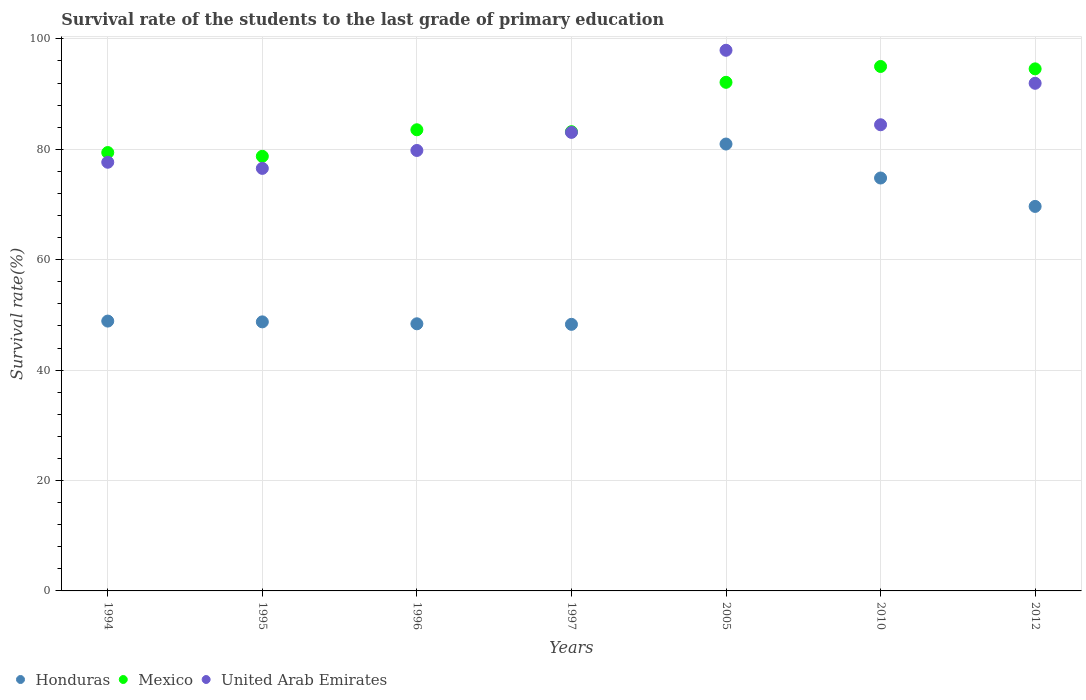How many different coloured dotlines are there?
Provide a succinct answer. 3. What is the survival rate of the students in Mexico in 2005?
Your response must be concise. 92.14. Across all years, what is the maximum survival rate of the students in Mexico?
Offer a terse response. 95.01. Across all years, what is the minimum survival rate of the students in Honduras?
Offer a very short reply. 48.29. In which year was the survival rate of the students in Mexico maximum?
Make the answer very short. 2010. In which year was the survival rate of the students in United Arab Emirates minimum?
Provide a succinct answer. 1995. What is the total survival rate of the students in United Arab Emirates in the graph?
Your answer should be very brief. 591.4. What is the difference between the survival rate of the students in Mexico in 1994 and that in 2010?
Offer a terse response. -15.59. What is the difference between the survival rate of the students in Mexico in 1997 and the survival rate of the students in Honduras in 2012?
Your response must be concise. 13.54. What is the average survival rate of the students in United Arab Emirates per year?
Give a very brief answer. 84.49. In the year 2010, what is the difference between the survival rate of the students in United Arab Emirates and survival rate of the students in Honduras?
Offer a terse response. 9.65. What is the ratio of the survival rate of the students in Mexico in 1994 to that in 1996?
Your answer should be very brief. 0.95. What is the difference between the highest and the second highest survival rate of the students in Mexico?
Your answer should be compact. 0.43. What is the difference between the highest and the lowest survival rate of the students in Mexico?
Make the answer very short. 16.28. In how many years, is the survival rate of the students in Mexico greater than the average survival rate of the students in Mexico taken over all years?
Offer a very short reply. 3. Is it the case that in every year, the sum of the survival rate of the students in Honduras and survival rate of the students in Mexico  is greater than the survival rate of the students in United Arab Emirates?
Ensure brevity in your answer.  Yes. Is the survival rate of the students in United Arab Emirates strictly less than the survival rate of the students in Honduras over the years?
Provide a short and direct response. No. How many dotlines are there?
Ensure brevity in your answer.  3. Are the values on the major ticks of Y-axis written in scientific E-notation?
Offer a terse response. No. Does the graph contain any zero values?
Keep it short and to the point. No. Does the graph contain grids?
Give a very brief answer. Yes. Where does the legend appear in the graph?
Provide a succinct answer. Bottom left. What is the title of the graph?
Ensure brevity in your answer.  Survival rate of the students to the last grade of primary education. Does "India" appear as one of the legend labels in the graph?
Make the answer very short. No. What is the label or title of the Y-axis?
Your answer should be compact. Survival rate(%). What is the Survival rate(%) of Honduras in 1994?
Your answer should be compact. 48.88. What is the Survival rate(%) in Mexico in 1994?
Provide a short and direct response. 79.41. What is the Survival rate(%) in United Arab Emirates in 1994?
Make the answer very short. 77.66. What is the Survival rate(%) in Honduras in 1995?
Make the answer very short. 48.74. What is the Survival rate(%) of Mexico in 1995?
Offer a terse response. 78.73. What is the Survival rate(%) of United Arab Emirates in 1995?
Your answer should be very brief. 76.54. What is the Survival rate(%) of Honduras in 1996?
Ensure brevity in your answer.  48.39. What is the Survival rate(%) in Mexico in 1996?
Ensure brevity in your answer.  83.54. What is the Survival rate(%) of United Arab Emirates in 1996?
Your response must be concise. 79.79. What is the Survival rate(%) in Honduras in 1997?
Provide a short and direct response. 48.29. What is the Survival rate(%) of Mexico in 1997?
Your answer should be compact. 83.19. What is the Survival rate(%) of United Arab Emirates in 1997?
Your answer should be very brief. 83.06. What is the Survival rate(%) of Honduras in 2005?
Make the answer very short. 80.96. What is the Survival rate(%) of Mexico in 2005?
Give a very brief answer. 92.14. What is the Survival rate(%) of United Arab Emirates in 2005?
Give a very brief answer. 97.94. What is the Survival rate(%) in Honduras in 2010?
Provide a succinct answer. 74.8. What is the Survival rate(%) of Mexico in 2010?
Offer a very short reply. 95.01. What is the Survival rate(%) of United Arab Emirates in 2010?
Keep it short and to the point. 84.45. What is the Survival rate(%) in Honduras in 2012?
Provide a succinct answer. 69.65. What is the Survival rate(%) in Mexico in 2012?
Your answer should be very brief. 94.57. What is the Survival rate(%) in United Arab Emirates in 2012?
Keep it short and to the point. 91.96. Across all years, what is the maximum Survival rate(%) of Honduras?
Your response must be concise. 80.96. Across all years, what is the maximum Survival rate(%) in Mexico?
Offer a terse response. 95.01. Across all years, what is the maximum Survival rate(%) in United Arab Emirates?
Provide a short and direct response. 97.94. Across all years, what is the minimum Survival rate(%) in Honduras?
Give a very brief answer. 48.29. Across all years, what is the minimum Survival rate(%) of Mexico?
Offer a very short reply. 78.73. Across all years, what is the minimum Survival rate(%) in United Arab Emirates?
Provide a short and direct response. 76.54. What is the total Survival rate(%) in Honduras in the graph?
Keep it short and to the point. 419.72. What is the total Survival rate(%) of Mexico in the graph?
Make the answer very short. 606.59. What is the total Survival rate(%) of United Arab Emirates in the graph?
Your response must be concise. 591.4. What is the difference between the Survival rate(%) of Honduras in 1994 and that in 1995?
Offer a very short reply. 0.14. What is the difference between the Survival rate(%) in Mexico in 1994 and that in 1995?
Make the answer very short. 0.68. What is the difference between the Survival rate(%) of United Arab Emirates in 1994 and that in 1995?
Your response must be concise. 1.11. What is the difference between the Survival rate(%) in Honduras in 1994 and that in 1996?
Offer a terse response. 0.49. What is the difference between the Survival rate(%) in Mexico in 1994 and that in 1996?
Your answer should be compact. -4.13. What is the difference between the Survival rate(%) of United Arab Emirates in 1994 and that in 1996?
Provide a short and direct response. -2.13. What is the difference between the Survival rate(%) in Honduras in 1994 and that in 1997?
Provide a short and direct response. 0.59. What is the difference between the Survival rate(%) in Mexico in 1994 and that in 1997?
Keep it short and to the point. -3.78. What is the difference between the Survival rate(%) in United Arab Emirates in 1994 and that in 1997?
Offer a terse response. -5.41. What is the difference between the Survival rate(%) in Honduras in 1994 and that in 2005?
Keep it short and to the point. -32.07. What is the difference between the Survival rate(%) in Mexico in 1994 and that in 2005?
Your answer should be compact. -12.72. What is the difference between the Survival rate(%) in United Arab Emirates in 1994 and that in 2005?
Keep it short and to the point. -20.28. What is the difference between the Survival rate(%) in Honduras in 1994 and that in 2010?
Provide a short and direct response. -25.92. What is the difference between the Survival rate(%) in Mexico in 1994 and that in 2010?
Your response must be concise. -15.59. What is the difference between the Survival rate(%) in United Arab Emirates in 1994 and that in 2010?
Offer a terse response. -6.79. What is the difference between the Survival rate(%) of Honduras in 1994 and that in 2012?
Offer a terse response. -20.77. What is the difference between the Survival rate(%) in Mexico in 1994 and that in 2012?
Ensure brevity in your answer.  -15.16. What is the difference between the Survival rate(%) of United Arab Emirates in 1994 and that in 2012?
Provide a short and direct response. -14.3. What is the difference between the Survival rate(%) in Honduras in 1995 and that in 1996?
Provide a short and direct response. 0.35. What is the difference between the Survival rate(%) of Mexico in 1995 and that in 1996?
Make the answer very short. -4.81. What is the difference between the Survival rate(%) of United Arab Emirates in 1995 and that in 1996?
Keep it short and to the point. -3.25. What is the difference between the Survival rate(%) of Honduras in 1995 and that in 1997?
Give a very brief answer. 0.45. What is the difference between the Survival rate(%) in Mexico in 1995 and that in 1997?
Provide a short and direct response. -4.46. What is the difference between the Survival rate(%) of United Arab Emirates in 1995 and that in 1997?
Your response must be concise. -6.52. What is the difference between the Survival rate(%) of Honduras in 1995 and that in 2005?
Your answer should be very brief. -32.22. What is the difference between the Survival rate(%) of Mexico in 1995 and that in 2005?
Give a very brief answer. -13.41. What is the difference between the Survival rate(%) in United Arab Emirates in 1995 and that in 2005?
Keep it short and to the point. -21.39. What is the difference between the Survival rate(%) of Honduras in 1995 and that in 2010?
Offer a very short reply. -26.06. What is the difference between the Survival rate(%) in Mexico in 1995 and that in 2010?
Offer a terse response. -16.28. What is the difference between the Survival rate(%) in United Arab Emirates in 1995 and that in 2010?
Offer a very short reply. -7.9. What is the difference between the Survival rate(%) in Honduras in 1995 and that in 2012?
Your answer should be very brief. -20.92. What is the difference between the Survival rate(%) in Mexico in 1995 and that in 2012?
Offer a terse response. -15.84. What is the difference between the Survival rate(%) of United Arab Emirates in 1995 and that in 2012?
Your answer should be very brief. -15.41. What is the difference between the Survival rate(%) of Honduras in 1996 and that in 1997?
Ensure brevity in your answer.  0.1. What is the difference between the Survival rate(%) of Mexico in 1996 and that in 1997?
Your answer should be very brief. 0.35. What is the difference between the Survival rate(%) in United Arab Emirates in 1996 and that in 1997?
Your response must be concise. -3.28. What is the difference between the Survival rate(%) in Honduras in 1996 and that in 2005?
Keep it short and to the point. -32.56. What is the difference between the Survival rate(%) in Mexico in 1996 and that in 2005?
Offer a terse response. -8.6. What is the difference between the Survival rate(%) of United Arab Emirates in 1996 and that in 2005?
Keep it short and to the point. -18.15. What is the difference between the Survival rate(%) of Honduras in 1996 and that in 2010?
Keep it short and to the point. -26.41. What is the difference between the Survival rate(%) of Mexico in 1996 and that in 2010?
Make the answer very short. -11.47. What is the difference between the Survival rate(%) of United Arab Emirates in 1996 and that in 2010?
Offer a very short reply. -4.66. What is the difference between the Survival rate(%) in Honduras in 1996 and that in 2012?
Ensure brevity in your answer.  -21.26. What is the difference between the Survival rate(%) of Mexico in 1996 and that in 2012?
Your answer should be very brief. -11.03. What is the difference between the Survival rate(%) of United Arab Emirates in 1996 and that in 2012?
Your answer should be compact. -12.17. What is the difference between the Survival rate(%) in Honduras in 1997 and that in 2005?
Your answer should be very brief. -32.66. What is the difference between the Survival rate(%) of Mexico in 1997 and that in 2005?
Provide a short and direct response. -8.95. What is the difference between the Survival rate(%) in United Arab Emirates in 1997 and that in 2005?
Provide a short and direct response. -14.87. What is the difference between the Survival rate(%) in Honduras in 1997 and that in 2010?
Ensure brevity in your answer.  -26.51. What is the difference between the Survival rate(%) of Mexico in 1997 and that in 2010?
Your answer should be compact. -11.82. What is the difference between the Survival rate(%) of United Arab Emirates in 1997 and that in 2010?
Give a very brief answer. -1.38. What is the difference between the Survival rate(%) in Honduras in 1997 and that in 2012?
Provide a short and direct response. -21.36. What is the difference between the Survival rate(%) of Mexico in 1997 and that in 2012?
Offer a very short reply. -11.38. What is the difference between the Survival rate(%) in United Arab Emirates in 1997 and that in 2012?
Ensure brevity in your answer.  -8.89. What is the difference between the Survival rate(%) in Honduras in 2005 and that in 2010?
Offer a terse response. 6.16. What is the difference between the Survival rate(%) of Mexico in 2005 and that in 2010?
Your answer should be very brief. -2.87. What is the difference between the Survival rate(%) in United Arab Emirates in 2005 and that in 2010?
Make the answer very short. 13.49. What is the difference between the Survival rate(%) of Honduras in 2005 and that in 2012?
Offer a terse response. 11.3. What is the difference between the Survival rate(%) of Mexico in 2005 and that in 2012?
Provide a short and direct response. -2.44. What is the difference between the Survival rate(%) of United Arab Emirates in 2005 and that in 2012?
Your response must be concise. 5.98. What is the difference between the Survival rate(%) of Honduras in 2010 and that in 2012?
Provide a short and direct response. 5.14. What is the difference between the Survival rate(%) in Mexico in 2010 and that in 2012?
Offer a terse response. 0.43. What is the difference between the Survival rate(%) of United Arab Emirates in 2010 and that in 2012?
Offer a terse response. -7.51. What is the difference between the Survival rate(%) in Honduras in 1994 and the Survival rate(%) in Mexico in 1995?
Your response must be concise. -29.85. What is the difference between the Survival rate(%) of Honduras in 1994 and the Survival rate(%) of United Arab Emirates in 1995?
Your answer should be compact. -27.66. What is the difference between the Survival rate(%) in Mexico in 1994 and the Survival rate(%) in United Arab Emirates in 1995?
Provide a succinct answer. 2.87. What is the difference between the Survival rate(%) of Honduras in 1994 and the Survival rate(%) of Mexico in 1996?
Offer a very short reply. -34.66. What is the difference between the Survival rate(%) of Honduras in 1994 and the Survival rate(%) of United Arab Emirates in 1996?
Your response must be concise. -30.91. What is the difference between the Survival rate(%) of Mexico in 1994 and the Survival rate(%) of United Arab Emirates in 1996?
Your answer should be very brief. -0.38. What is the difference between the Survival rate(%) in Honduras in 1994 and the Survival rate(%) in Mexico in 1997?
Give a very brief answer. -34.31. What is the difference between the Survival rate(%) of Honduras in 1994 and the Survival rate(%) of United Arab Emirates in 1997?
Provide a succinct answer. -34.18. What is the difference between the Survival rate(%) in Mexico in 1994 and the Survival rate(%) in United Arab Emirates in 1997?
Make the answer very short. -3.65. What is the difference between the Survival rate(%) of Honduras in 1994 and the Survival rate(%) of Mexico in 2005?
Ensure brevity in your answer.  -43.25. What is the difference between the Survival rate(%) of Honduras in 1994 and the Survival rate(%) of United Arab Emirates in 2005?
Provide a succinct answer. -49.06. What is the difference between the Survival rate(%) in Mexico in 1994 and the Survival rate(%) in United Arab Emirates in 2005?
Offer a terse response. -18.53. What is the difference between the Survival rate(%) in Honduras in 1994 and the Survival rate(%) in Mexico in 2010?
Keep it short and to the point. -46.12. What is the difference between the Survival rate(%) in Honduras in 1994 and the Survival rate(%) in United Arab Emirates in 2010?
Your answer should be compact. -35.56. What is the difference between the Survival rate(%) of Mexico in 1994 and the Survival rate(%) of United Arab Emirates in 2010?
Ensure brevity in your answer.  -5.03. What is the difference between the Survival rate(%) in Honduras in 1994 and the Survival rate(%) in Mexico in 2012?
Offer a terse response. -45.69. What is the difference between the Survival rate(%) in Honduras in 1994 and the Survival rate(%) in United Arab Emirates in 2012?
Offer a terse response. -43.08. What is the difference between the Survival rate(%) of Mexico in 1994 and the Survival rate(%) of United Arab Emirates in 2012?
Give a very brief answer. -12.55. What is the difference between the Survival rate(%) of Honduras in 1995 and the Survival rate(%) of Mexico in 1996?
Your answer should be compact. -34.8. What is the difference between the Survival rate(%) in Honduras in 1995 and the Survival rate(%) in United Arab Emirates in 1996?
Provide a short and direct response. -31.05. What is the difference between the Survival rate(%) of Mexico in 1995 and the Survival rate(%) of United Arab Emirates in 1996?
Make the answer very short. -1.06. What is the difference between the Survival rate(%) in Honduras in 1995 and the Survival rate(%) in Mexico in 1997?
Give a very brief answer. -34.45. What is the difference between the Survival rate(%) in Honduras in 1995 and the Survival rate(%) in United Arab Emirates in 1997?
Your answer should be very brief. -34.33. What is the difference between the Survival rate(%) of Mexico in 1995 and the Survival rate(%) of United Arab Emirates in 1997?
Your answer should be very brief. -4.33. What is the difference between the Survival rate(%) of Honduras in 1995 and the Survival rate(%) of Mexico in 2005?
Offer a terse response. -43.4. What is the difference between the Survival rate(%) of Honduras in 1995 and the Survival rate(%) of United Arab Emirates in 2005?
Keep it short and to the point. -49.2. What is the difference between the Survival rate(%) in Mexico in 1995 and the Survival rate(%) in United Arab Emirates in 2005?
Keep it short and to the point. -19.21. What is the difference between the Survival rate(%) of Honduras in 1995 and the Survival rate(%) of Mexico in 2010?
Provide a short and direct response. -46.27. What is the difference between the Survival rate(%) in Honduras in 1995 and the Survival rate(%) in United Arab Emirates in 2010?
Ensure brevity in your answer.  -35.71. What is the difference between the Survival rate(%) in Mexico in 1995 and the Survival rate(%) in United Arab Emirates in 2010?
Your answer should be very brief. -5.72. What is the difference between the Survival rate(%) in Honduras in 1995 and the Survival rate(%) in Mexico in 2012?
Provide a short and direct response. -45.83. What is the difference between the Survival rate(%) in Honduras in 1995 and the Survival rate(%) in United Arab Emirates in 2012?
Give a very brief answer. -43.22. What is the difference between the Survival rate(%) of Mexico in 1995 and the Survival rate(%) of United Arab Emirates in 2012?
Ensure brevity in your answer.  -13.23. What is the difference between the Survival rate(%) in Honduras in 1996 and the Survival rate(%) in Mexico in 1997?
Offer a very short reply. -34.8. What is the difference between the Survival rate(%) of Honduras in 1996 and the Survival rate(%) of United Arab Emirates in 1997?
Keep it short and to the point. -34.67. What is the difference between the Survival rate(%) of Mexico in 1996 and the Survival rate(%) of United Arab Emirates in 1997?
Offer a very short reply. 0.47. What is the difference between the Survival rate(%) of Honduras in 1996 and the Survival rate(%) of Mexico in 2005?
Give a very brief answer. -43.74. What is the difference between the Survival rate(%) in Honduras in 1996 and the Survival rate(%) in United Arab Emirates in 2005?
Your answer should be very brief. -49.55. What is the difference between the Survival rate(%) in Mexico in 1996 and the Survival rate(%) in United Arab Emirates in 2005?
Offer a very short reply. -14.4. What is the difference between the Survival rate(%) in Honduras in 1996 and the Survival rate(%) in Mexico in 2010?
Ensure brevity in your answer.  -46.61. What is the difference between the Survival rate(%) in Honduras in 1996 and the Survival rate(%) in United Arab Emirates in 2010?
Your answer should be very brief. -36.05. What is the difference between the Survival rate(%) of Mexico in 1996 and the Survival rate(%) of United Arab Emirates in 2010?
Ensure brevity in your answer.  -0.91. What is the difference between the Survival rate(%) in Honduras in 1996 and the Survival rate(%) in Mexico in 2012?
Provide a succinct answer. -46.18. What is the difference between the Survival rate(%) in Honduras in 1996 and the Survival rate(%) in United Arab Emirates in 2012?
Your answer should be very brief. -43.57. What is the difference between the Survival rate(%) of Mexico in 1996 and the Survival rate(%) of United Arab Emirates in 2012?
Make the answer very short. -8.42. What is the difference between the Survival rate(%) of Honduras in 1997 and the Survival rate(%) of Mexico in 2005?
Keep it short and to the point. -43.84. What is the difference between the Survival rate(%) in Honduras in 1997 and the Survival rate(%) in United Arab Emirates in 2005?
Your answer should be compact. -49.65. What is the difference between the Survival rate(%) of Mexico in 1997 and the Survival rate(%) of United Arab Emirates in 2005?
Provide a succinct answer. -14.75. What is the difference between the Survival rate(%) in Honduras in 1997 and the Survival rate(%) in Mexico in 2010?
Your answer should be very brief. -46.71. What is the difference between the Survival rate(%) of Honduras in 1997 and the Survival rate(%) of United Arab Emirates in 2010?
Your answer should be compact. -36.15. What is the difference between the Survival rate(%) in Mexico in 1997 and the Survival rate(%) in United Arab Emirates in 2010?
Offer a terse response. -1.26. What is the difference between the Survival rate(%) in Honduras in 1997 and the Survival rate(%) in Mexico in 2012?
Give a very brief answer. -46.28. What is the difference between the Survival rate(%) of Honduras in 1997 and the Survival rate(%) of United Arab Emirates in 2012?
Make the answer very short. -43.67. What is the difference between the Survival rate(%) of Mexico in 1997 and the Survival rate(%) of United Arab Emirates in 2012?
Keep it short and to the point. -8.77. What is the difference between the Survival rate(%) of Honduras in 2005 and the Survival rate(%) of Mexico in 2010?
Provide a short and direct response. -14.05. What is the difference between the Survival rate(%) in Honduras in 2005 and the Survival rate(%) in United Arab Emirates in 2010?
Provide a short and direct response. -3.49. What is the difference between the Survival rate(%) of Mexico in 2005 and the Survival rate(%) of United Arab Emirates in 2010?
Your response must be concise. 7.69. What is the difference between the Survival rate(%) of Honduras in 2005 and the Survival rate(%) of Mexico in 2012?
Provide a short and direct response. -13.62. What is the difference between the Survival rate(%) of Honduras in 2005 and the Survival rate(%) of United Arab Emirates in 2012?
Give a very brief answer. -11. What is the difference between the Survival rate(%) in Mexico in 2005 and the Survival rate(%) in United Arab Emirates in 2012?
Your response must be concise. 0.18. What is the difference between the Survival rate(%) in Honduras in 2010 and the Survival rate(%) in Mexico in 2012?
Give a very brief answer. -19.77. What is the difference between the Survival rate(%) of Honduras in 2010 and the Survival rate(%) of United Arab Emirates in 2012?
Offer a terse response. -17.16. What is the difference between the Survival rate(%) of Mexico in 2010 and the Survival rate(%) of United Arab Emirates in 2012?
Give a very brief answer. 3.05. What is the average Survival rate(%) in Honduras per year?
Ensure brevity in your answer.  59.96. What is the average Survival rate(%) in Mexico per year?
Provide a short and direct response. 86.66. What is the average Survival rate(%) in United Arab Emirates per year?
Make the answer very short. 84.49. In the year 1994, what is the difference between the Survival rate(%) of Honduras and Survival rate(%) of Mexico?
Ensure brevity in your answer.  -30.53. In the year 1994, what is the difference between the Survival rate(%) of Honduras and Survival rate(%) of United Arab Emirates?
Make the answer very short. -28.77. In the year 1994, what is the difference between the Survival rate(%) in Mexico and Survival rate(%) in United Arab Emirates?
Your answer should be very brief. 1.76. In the year 1995, what is the difference between the Survival rate(%) of Honduras and Survival rate(%) of Mexico?
Provide a short and direct response. -29.99. In the year 1995, what is the difference between the Survival rate(%) of Honduras and Survival rate(%) of United Arab Emirates?
Offer a terse response. -27.81. In the year 1995, what is the difference between the Survival rate(%) in Mexico and Survival rate(%) in United Arab Emirates?
Provide a succinct answer. 2.19. In the year 1996, what is the difference between the Survival rate(%) in Honduras and Survival rate(%) in Mexico?
Provide a succinct answer. -35.15. In the year 1996, what is the difference between the Survival rate(%) in Honduras and Survival rate(%) in United Arab Emirates?
Offer a terse response. -31.4. In the year 1996, what is the difference between the Survival rate(%) of Mexico and Survival rate(%) of United Arab Emirates?
Provide a short and direct response. 3.75. In the year 1997, what is the difference between the Survival rate(%) of Honduras and Survival rate(%) of Mexico?
Your response must be concise. -34.9. In the year 1997, what is the difference between the Survival rate(%) of Honduras and Survival rate(%) of United Arab Emirates?
Provide a short and direct response. -34.77. In the year 1997, what is the difference between the Survival rate(%) of Mexico and Survival rate(%) of United Arab Emirates?
Keep it short and to the point. 0.13. In the year 2005, what is the difference between the Survival rate(%) in Honduras and Survival rate(%) in Mexico?
Offer a terse response. -11.18. In the year 2005, what is the difference between the Survival rate(%) in Honduras and Survival rate(%) in United Arab Emirates?
Your answer should be very brief. -16.98. In the year 2005, what is the difference between the Survival rate(%) of Mexico and Survival rate(%) of United Arab Emirates?
Make the answer very short. -5.8. In the year 2010, what is the difference between the Survival rate(%) of Honduras and Survival rate(%) of Mexico?
Your answer should be very brief. -20.21. In the year 2010, what is the difference between the Survival rate(%) in Honduras and Survival rate(%) in United Arab Emirates?
Your response must be concise. -9.65. In the year 2010, what is the difference between the Survival rate(%) of Mexico and Survival rate(%) of United Arab Emirates?
Give a very brief answer. 10.56. In the year 2012, what is the difference between the Survival rate(%) in Honduras and Survival rate(%) in Mexico?
Your answer should be compact. -24.92. In the year 2012, what is the difference between the Survival rate(%) of Honduras and Survival rate(%) of United Arab Emirates?
Provide a succinct answer. -22.3. In the year 2012, what is the difference between the Survival rate(%) of Mexico and Survival rate(%) of United Arab Emirates?
Provide a succinct answer. 2.61. What is the ratio of the Survival rate(%) of Honduras in 1994 to that in 1995?
Ensure brevity in your answer.  1. What is the ratio of the Survival rate(%) of Mexico in 1994 to that in 1995?
Ensure brevity in your answer.  1.01. What is the ratio of the Survival rate(%) of United Arab Emirates in 1994 to that in 1995?
Offer a terse response. 1.01. What is the ratio of the Survival rate(%) of Mexico in 1994 to that in 1996?
Offer a terse response. 0.95. What is the ratio of the Survival rate(%) in United Arab Emirates in 1994 to that in 1996?
Give a very brief answer. 0.97. What is the ratio of the Survival rate(%) in Honduras in 1994 to that in 1997?
Ensure brevity in your answer.  1.01. What is the ratio of the Survival rate(%) of Mexico in 1994 to that in 1997?
Ensure brevity in your answer.  0.95. What is the ratio of the Survival rate(%) of United Arab Emirates in 1994 to that in 1997?
Give a very brief answer. 0.93. What is the ratio of the Survival rate(%) in Honduras in 1994 to that in 2005?
Your answer should be very brief. 0.6. What is the ratio of the Survival rate(%) in Mexico in 1994 to that in 2005?
Offer a terse response. 0.86. What is the ratio of the Survival rate(%) of United Arab Emirates in 1994 to that in 2005?
Provide a short and direct response. 0.79. What is the ratio of the Survival rate(%) of Honduras in 1994 to that in 2010?
Your response must be concise. 0.65. What is the ratio of the Survival rate(%) in Mexico in 1994 to that in 2010?
Keep it short and to the point. 0.84. What is the ratio of the Survival rate(%) in United Arab Emirates in 1994 to that in 2010?
Offer a terse response. 0.92. What is the ratio of the Survival rate(%) in Honduras in 1994 to that in 2012?
Offer a terse response. 0.7. What is the ratio of the Survival rate(%) in Mexico in 1994 to that in 2012?
Offer a very short reply. 0.84. What is the ratio of the Survival rate(%) in United Arab Emirates in 1994 to that in 2012?
Your response must be concise. 0.84. What is the ratio of the Survival rate(%) of Honduras in 1995 to that in 1996?
Offer a terse response. 1.01. What is the ratio of the Survival rate(%) of Mexico in 1995 to that in 1996?
Provide a succinct answer. 0.94. What is the ratio of the Survival rate(%) in United Arab Emirates in 1995 to that in 1996?
Provide a short and direct response. 0.96. What is the ratio of the Survival rate(%) in Honduras in 1995 to that in 1997?
Give a very brief answer. 1.01. What is the ratio of the Survival rate(%) in Mexico in 1995 to that in 1997?
Make the answer very short. 0.95. What is the ratio of the Survival rate(%) in United Arab Emirates in 1995 to that in 1997?
Ensure brevity in your answer.  0.92. What is the ratio of the Survival rate(%) of Honduras in 1995 to that in 2005?
Make the answer very short. 0.6. What is the ratio of the Survival rate(%) in Mexico in 1995 to that in 2005?
Your answer should be very brief. 0.85. What is the ratio of the Survival rate(%) in United Arab Emirates in 1995 to that in 2005?
Offer a very short reply. 0.78. What is the ratio of the Survival rate(%) of Honduras in 1995 to that in 2010?
Offer a terse response. 0.65. What is the ratio of the Survival rate(%) of Mexico in 1995 to that in 2010?
Your response must be concise. 0.83. What is the ratio of the Survival rate(%) of United Arab Emirates in 1995 to that in 2010?
Ensure brevity in your answer.  0.91. What is the ratio of the Survival rate(%) of Honduras in 1995 to that in 2012?
Offer a very short reply. 0.7. What is the ratio of the Survival rate(%) of Mexico in 1995 to that in 2012?
Provide a succinct answer. 0.83. What is the ratio of the Survival rate(%) of United Arab Emirates in 1995 to that in 2012?
Give a very brief answer. 0.83. What is the ratio of the Survival rate(%) in Honduras in 1996 to that in 1997?
Your response must be concise. 1. What is the ratio of the Survival rate(%) in United Arab Emirates in 1996 to that in 1997?
Keep it short and to the point. 0.96. What is the ratio of the Survival rate(%) in Honduras in 1996 to that in 2005?
Keep it short and to the point. 0.6. What is the ratio of the Survival rate(%) of Mexico in 1996 to that in 2005?
Your answer should be very brief. 0.91. What is the ratio of the Survival rate(%) of United Arab Emirates in 1996 to that in 2005?
Give a very brief answer. 0.81. What is the ratio of the Survival rate(%) in Honduras in 1996 to that in 2010?
Keep it short and to the point. 0.65. What is the ratio of the Survival rate(%) in Mexico in 1996 to that in 2010?
Offer a very short reply. 0.88. What is the ratio of the Survival rate(%) in United Arab Emirates in 1996 to that in 2010?
Offer a terse response. 0.94. What is the ratio of the Survival rate(%) in Honduras in 1996 to that in 2012?
Offer a terse response. 0.69. What is the ratio of the Survival rate(%) of Mexico in 1996 to that in 2012?
Your answer should be very brief. 0.88. What is the ratio of the Survival rate(%) of United Arab Emirates in 1996 to that in 2012?
Provide a short and direct response. 0.87. What is the ratio of the Survival rate(%) of Honduras in 1997 to that in 2005?
Keep it short and to the point. 0.6. What is the ratio of the Survival rate(%) in Mexico in 1997 to that in 2005?
Ensure brevity in your answer.  0.9. What is the ratio of the Survival rate(%) in United Arab Emirates in 1997 to that in 2005?
Give a very brief answer. 0.85. What is the ratio of the Survival rate(%) of Honduras in 1997 to that in 2010?
Make the answer very short. 0.65. What is the ratio of the Survival rate(%) of Mexico in 1997 to that in 2010?
Keep it short and to the point. 0.88. What is the ratio of the Survival rate(%) of United Arab Emirates in 1997 to that in 2010?
Offer a terse response. 0.98. What is the ratio of the Survival rate(%) of Honduras in 1997 to that in 2012?
Keep it short and to the point. 0.69. What is the ratio of the Survival rate(%) of Mexico in 1997 to that in 2012?
Offer a very short reply. 0.88. What is the ratio of the Survival rate(%) of United Arab Emirates in 1997 to that in 2012?
Make the answer very short. 0.9. What is the ratio of the Survival rate(%) in Honduras in 2005 to that in 2010?
Give a very brief answer. 1.08. What is the ratio of the Survival rate(%) of Mexico in 2005 to that in 2010?
Your answer should be very brief. 0.97. What is the ratio of the Survival rate(%) in United Arab Emirates in 2005 to that in 2010?
Your answer should be very brief. 1.16. What is the ratio of the Survival rate(%) in Honduras in 2005 to that in 2012?
Ensure brevity in your answer.  1.16. What is the ratio of the Survival rate(%) in Mexico in 2005 to that in 2012?
Offer a terse response. 0.97. What is the ratio of the Survival rate(%) in United Arab Emirates in 2005 to that in 2012?
Keep it short and to the point. 1.06. What is the ratio of the Survival rate(%) of Honduras in 2010 to that in 2012?
Give a very brief answer. 1.07. What is the ratio of the Survival rate(%) of Mexico in 2010 to that in 2012?
Provide a succinct answer. 1. What is the ratio of the Survival rate(%) in United Arab Emirates in 2010 to that in 2012?
Offer a terse response. 0.92. What is the difference between the highest and the second highest Survival rate(%) of Honduras?
Make the answer very short. 6.16. What is the difference between the highest and the second highest Survival rate(%) of Mexico?
Your answer should be compact. 0.43. What is the difference between the highest and the second highest Survival rate(%) in United Arab Emirates?
Give a very brief answer. 5.98. What is the difference between the highest and the lowest Survival rate(%) of Honduras?
Provide a short and direct response. 32.66. What is the difference between the highest and the lowest Survival rate(%) in Mexico?
Give a very brief answer. 16.28. What is the difference between the highest and the lowest Survival rate(%) in United Arab Emirates?
Offer a very short reply. 21.39. 